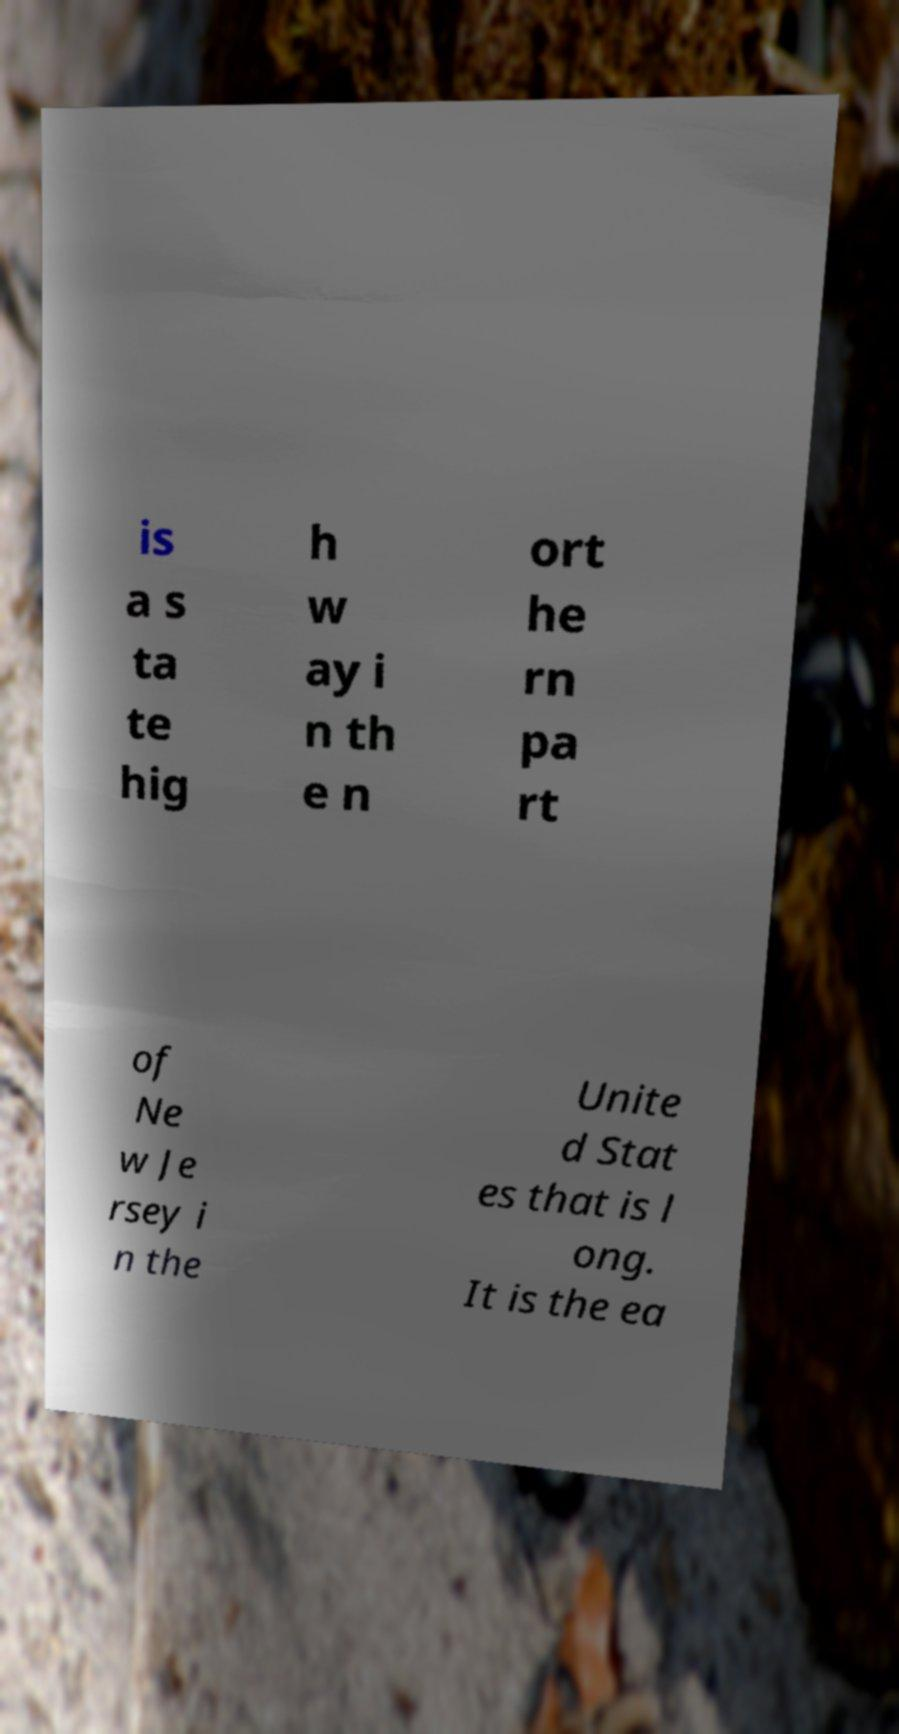Can you accurately transcribe the text from the provided image for me? is a s ta te hig h w ay i n th e n ort he rn pa rt of Ne w Je rsey i n the Unite d Stat es that is l ong. It is the ea 